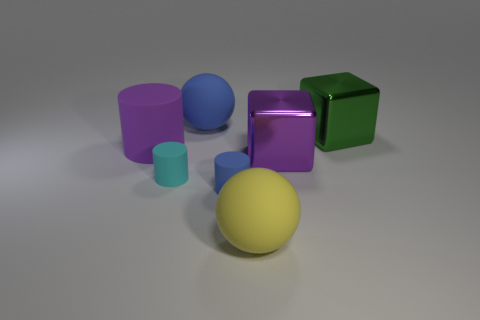There is a rubber thing that is both behind the large yellow matte sphere and on the right side of the large blue rubber thing; how big is it?
Offer a terse response. Small. The object that is behind the big yellow sphere and in front of the cyan cylinder has what shape?
Offer a very short reply. Cylinder. Is there a large cube behind the large sphere that is behind the large object in front of the tiny blue cylinder?
Your answer should be compact. No. What number of objects are either purple things that are right of the big blue object or big metallic things that are behind the purple cube?
Your answer should be very brief. 2. Is the material of the large purple object on the left side of the blue matte cylinder the same as the big yellow thing?
Provide a short and direct response. Yes. The object that is behind the purple rubber cylinder and in front of the large blue thing is made of what material?
Keep it short and to the point. Metal. There is a big sphere that is behind the large rubber ball that is in front of the blue rubber cylinder; what color is it?
Ensure brevity in your answer.  Blue. There is another object that is the same shape as the yellow thing; what is its material?
Provide a succinct answer. Rubber. There is a metal thing that is to the right of the large purple object that is to the right of the tiny rubber cylinder behind the small blue rubber thing; what is its color?
Keep it short and to the point. Green. What number of objects are tiny red rubber balls or small rubber cylinders?
Keep it short and to the point. 2. 